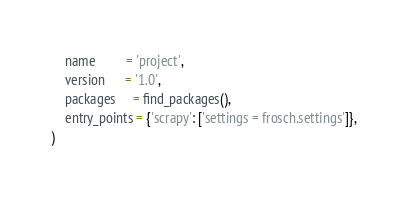<code> <loc_0><loc_0><loc_500><loc_500><_Python_>    name         = 'project',
    version      = '1.0',
    packages     = find_packages(),
    entry_points = {'scrapy': ['settings = frosch.settings']},
)
</code> 